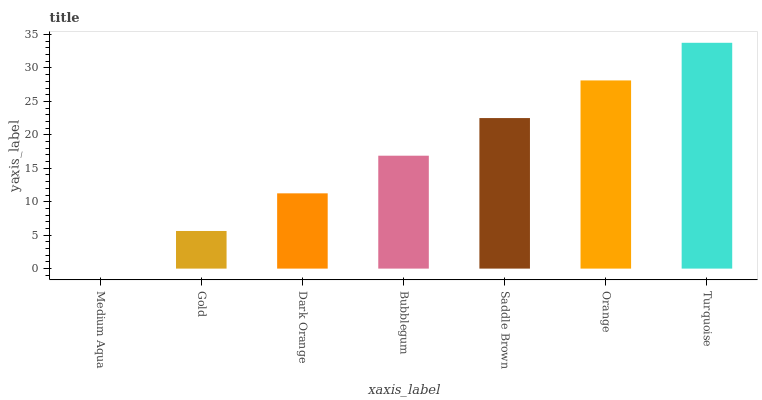Is Medium Aqua the minimum?
Answer yes or no. Yes. Is Turquoise the maximum?
Answer yes or no. Yes. Is Gold the minimum?
Answer yes or no. No. Is Gold the maximum?
Answer yes or no. No. Is Gold greater than Medium Aqua?
Answer yes or no. Yes. Is Medium Aqua less than Gold?
Answer yes or no. Yes. Is Medium Aqua greater than Gold?
Answer yes or no. No. Is Gold less than Medium Aqua?
Answer yes or no. No. Is Bubblegum the high median?
Answer yes or no. Yes. Is Bubblegum the low median?
Answer yes or no. Yes. Is Dark Orange the high median?
Answer yes or no. No. Is Orange the low median?
Answer yes or no. No. 